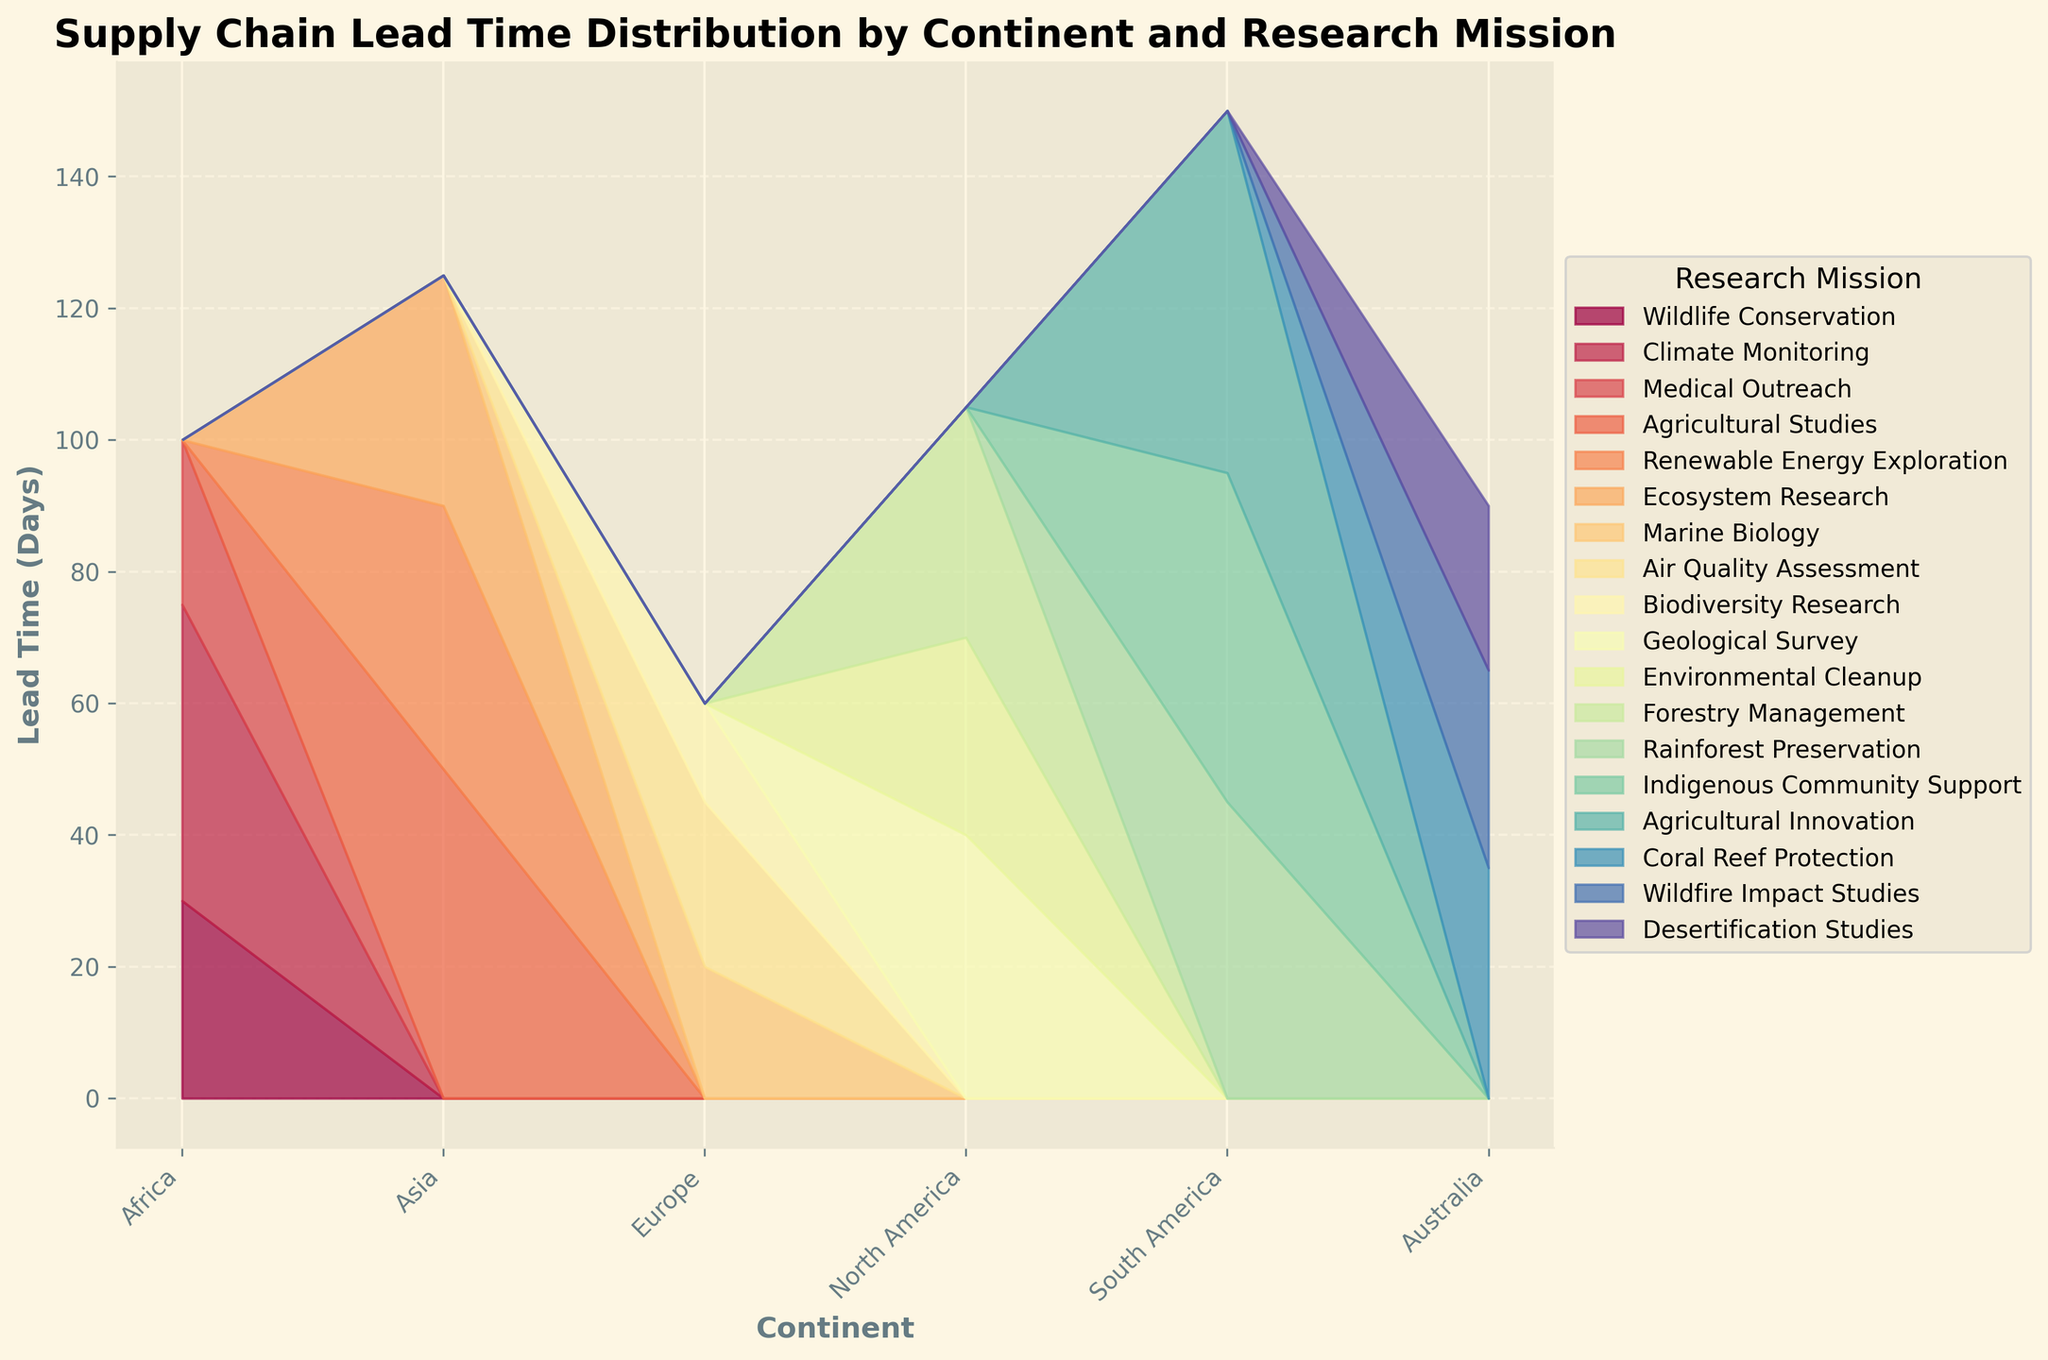What's the title of the figure? The title of the figure is displayed at the top of the chart in bold text. It is "Supply Chain Lead Time Distribution by Continent and Research Mission".
Answer: Supply Chain Lead Time Distribution by Continent and Research Mission Which continent has the highest total lead time in days? By looking at the stacked area chart, we can see that the continent with the tallest combined stack height, which represents the highest total lead time, is South America.
Answer: South America What is the lead time for Wildlife Conservation in Africa? Within the Africa section of the stacked area chart, the segment representing Wildlife Conservation is at the bottom. Its height corresponds to the lead time of 30 days.
Answer: 30 days Among the research missions in Europe, which has the shortest lead time? Looking at the segments within the Europe section of the chart, the shortest segment corresponds to Biodiversity Research with a lead time of 15 days.
Answer: Biodiversity Research What is the average lead time for research missions in Australia? The lead times for missions in Australia are 35, 30, and 25 days. Adding these together gives 90, and dividing by 3 results in an average lead time of 30 days.
Answer: 30 days Which research mission has the greatest variation in lead time across continents? By observing the variation in segment heights across the continents, it can be seen that the segments for Agricultural Studies, which are in the Asia and South America regions, show significant variation.
Answer: Agricultural Studies Compare the total lead time for all research missions between North America and Europe. Summing up the heights of all segments for North America (40 + 30 + 35 = 105) and Europe (20 + 25 + 15 = 60), we see that North America's total lead time is greater than Europe's.
Answer: North America How does the lead time for Medical Outreach in Africa compare to that for Wildfire Impact Studies in Australia? The chart shows that Medical Outreach in Africa has a lead time of 25 days, while Wildfire Impact Studies in Australia has a lead time of 30 days. Therefore, Medical Outreach in Africa has a shorter lead time.
Answer: Medical Outreach in Africa has a shorter lead time What is the cumulative lead time for all research missions in Asia? Adding up the lead times for all research missions in Asia (50 + 40 + 35), we get a total of 125 days.
Answer: 125 days 